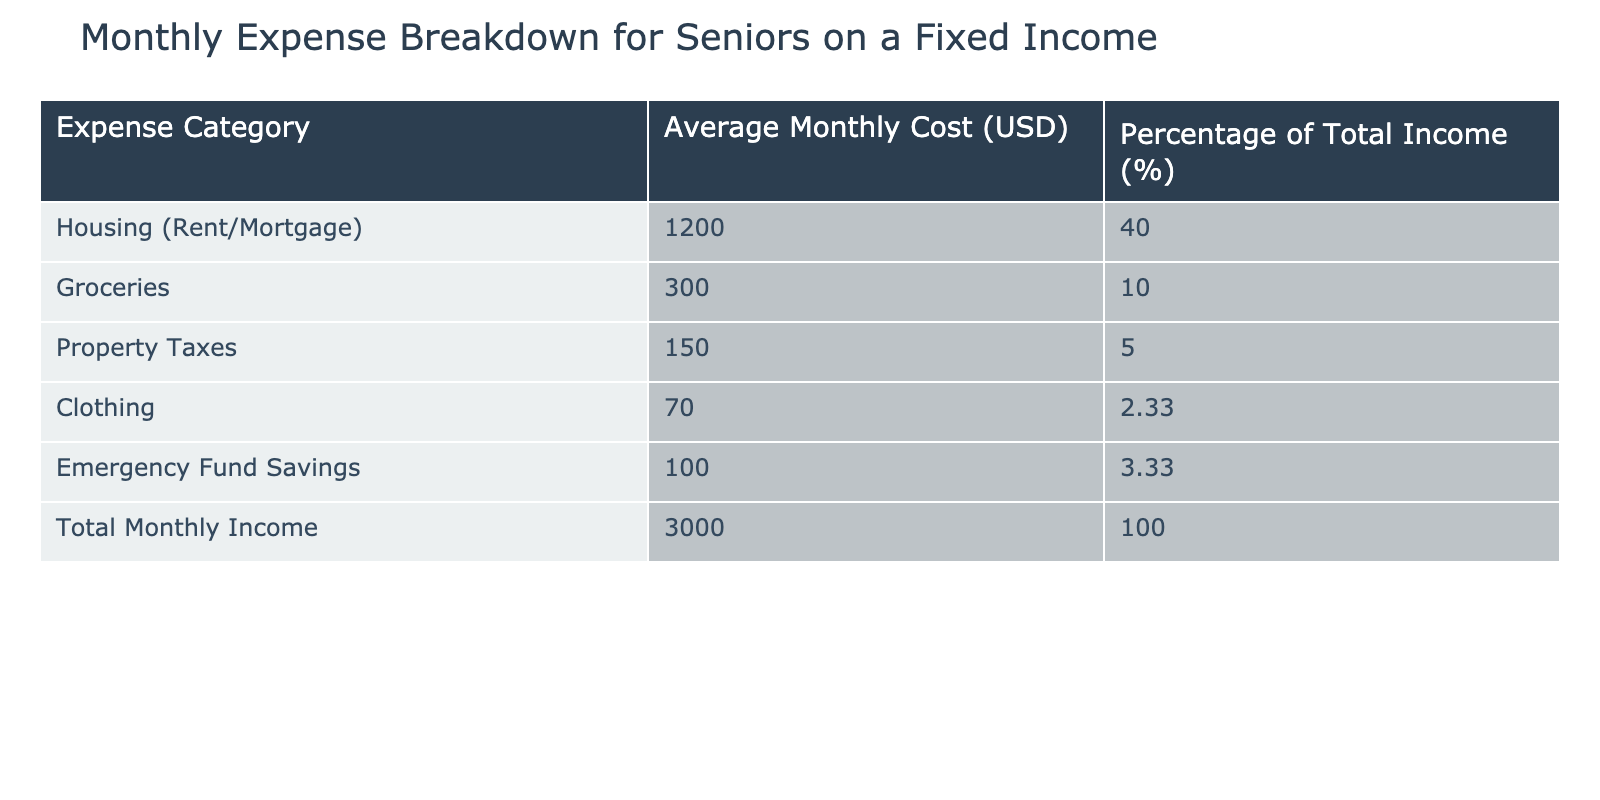What is the average monthly cost for housing? The table specifies that the average monthly cost for housing (Rent/Mortgage) is 1200 USD. This value is directly listed in the corresponding row under Average Monthly Cost.
Answer: 1200 USD What percentage of total income is spent on groceries? The table states that the percentage of total income spent on groceries is 10%. This value can be found in the row that lists Groceries under Percentage of Total Income.
Answer: 10% If the total monthly income is 3000 USD, how much is allocated for emergency fund savings? The table shows that the average monthly cost for Emergency Fund Savings is 100 USD, which can be directly referenced from the relevant row in the table.
Answer: 100 USD What is the combined monthly cost for property taxes and clothing? To find the combined cost, we add the average monthly cost for Property Taxes (150 USD) and Clothing (70 USD). Adding these gives us 150 + 70 = 220 USD.
Answer: 220 USD Is clothing spending greater than emergency fund savings? The table indicates that the average monthly cost for clothing is 70 USD and for Emergency Fund Savings is 100 USD. Since 70 is less than 100, the answer is no.
Answer: No What is the total amount spent on housing, groceries, and property taxes? We sum the average monthly costs for Housing (1200 USD), Groceries (300 USD), and Property Taxes (150 USD). Adding these figures gives us 1200 + 300 + 150 = 1650 USD.
Answer: 1650 USD Does the total monthly income exceed the sum of all listed expenses? The total monthly income is 3000 USD. To verify if it exceeds the total of all listed expenses, we sum them up: Housing (1200 USD) + Groceries (300 USD) + Property Taxes (150 USD) + Clothing (70 USD) + Emergency Fund Savings (100 USD) = 1820 USD. Since 3000 USD is greater than 1820 USD, the answer is yes.
Answer: Yes How much is left after spending on all expenses from the total income? First, we calculate total expenses as previously calculated (1820 USD). Then, we subtract this from the total monthly income (3000 USD): 3000 - 1820 = 1180 USD. This gives us the amount left after expenses.
Answer: 1180 USD What percentage of total income is represented by the sum of clothing and emergency fund savings? The average monthly costs for Clothing (70 USD) and Emergency Fund Savings (100 USD) add up to 170 USD. To find the percentage relative to the total monthly income of 3000 USD, we calculate (170/3000) * 100 = 5.67%. Therefore, the percentage is approximately 5.67%.
Answer: 5.67% 